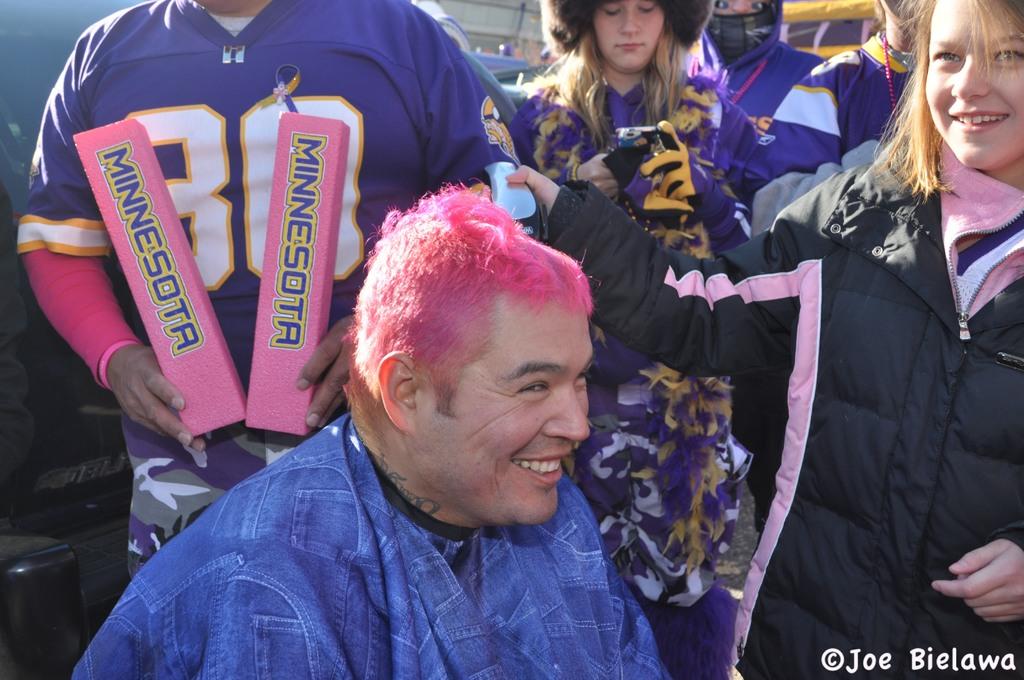What state is on the foam pylons in the man's hands?
Your answer should be compact. Minnesota. What is the name of the photographer credited in the bottom right?
Provide a short and direct response. Joe bielawa. 